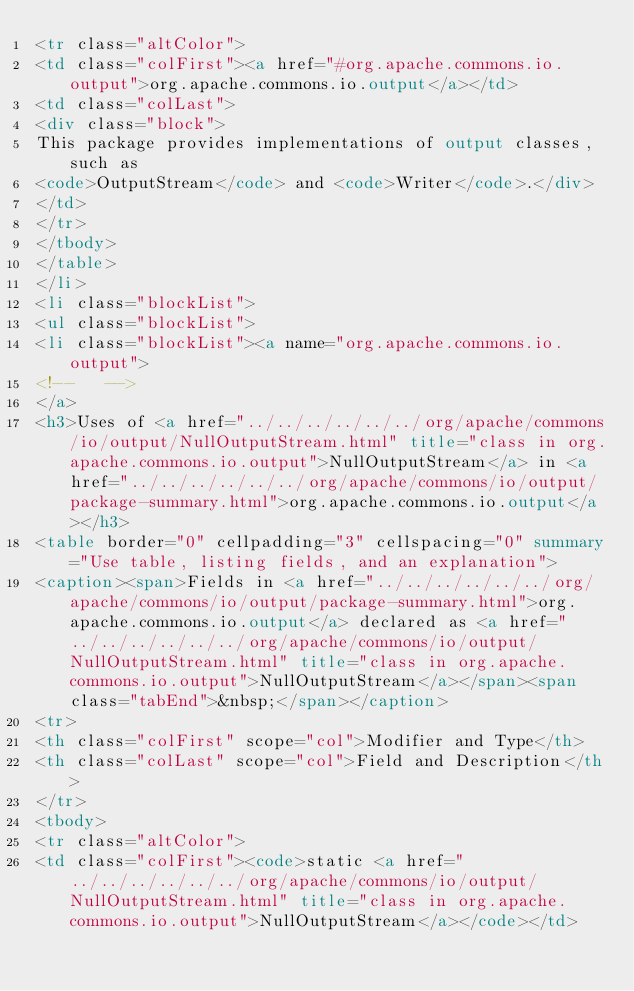<code> <loc_0><loc_0><loc_500><loc_500><_HTML_><tr class="altColor">
<td class="colFirst"><a href="#org.apache.commons.io.output">org.apache.commons.io.output</a></td>
<td class="colLast">
<div class="block">
This package provides implementations of output classes, such as
<code>OutputStream</code> and <code>Writer</code>.</div>
</td>
</tr>
</tbody>
</table>
</li>
<li class="blockList">
<ul class="blockList">
<li class="blockList"><a name="org.apache.commons.io.output">
<!--   -->
</a>
<h3>Uses of <a href="../../../../../../org/apache/commons/io/output/NullOutputStream.html" title="class in org.apache.commons.io.output">NullOutputStream</a> in <a href="../../../../../../org/apache/commons/io/output/package-summary.html">org.apache.commons.io.output</a></h3>
<table border="0" cellpadding="3" cellspacing="0" summary="Use table, listing fields, and an explanation">
<caption><span>Fields in <a href="../../../../../../org/apache/commons/io/output/package-summary.html">org.apache.commons.io.output</a> declared as <a href="../../../../../../org/apache/commons/io/output/NullOutputStream.html" title="class in org.apache.commons.io.output">NullOutputStream</a></span><span class="tabEnd">&nbsp;</span></caption>
<tr>
<th class="colFirst" scope="col">Modifier and Type</th>
<th class="colLast" scope="col">Field and Description</th>
</tr>
<tbody>
<tr class="altColor">
<td class="colFirst"><code>static <a href="../../../../../../org/apache/commons/io/output/NullOutputStream.html" title="class in org.apache.commons.io.output">NullOutputStream</a></code></td></code> 